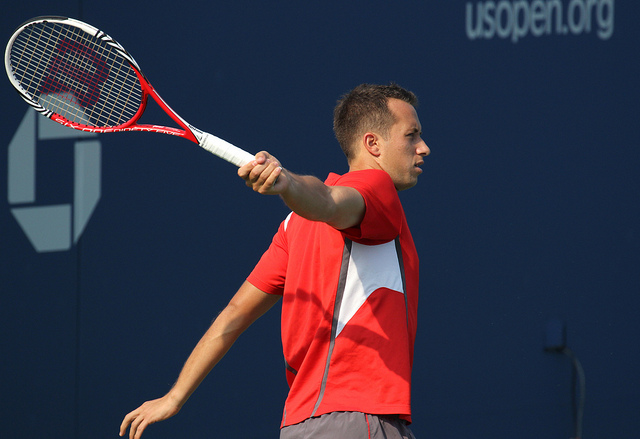Read and extract the text from this image. usopen.org B 